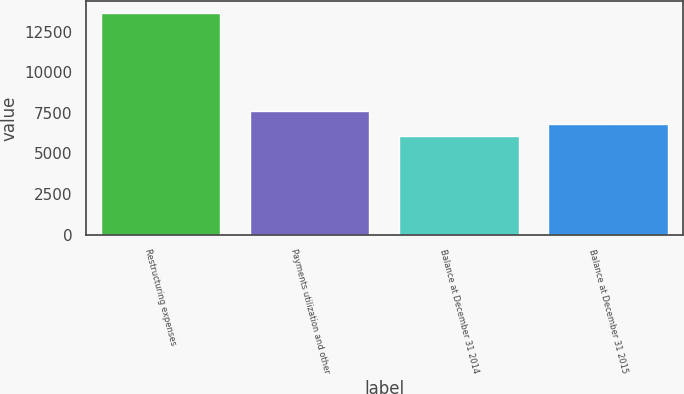<chart> <loc_0><loc_0><loc_500><loc_500><bar_chart><fcel>Restructuring expenses<fcel>Payments utilization and other<fcel>Balance at December 31 2014<fcel>Balance at December 31 2015<nl><fcel>13672<fcel>7616<fcel>6056<fcel>6817.6<nl></chart> 